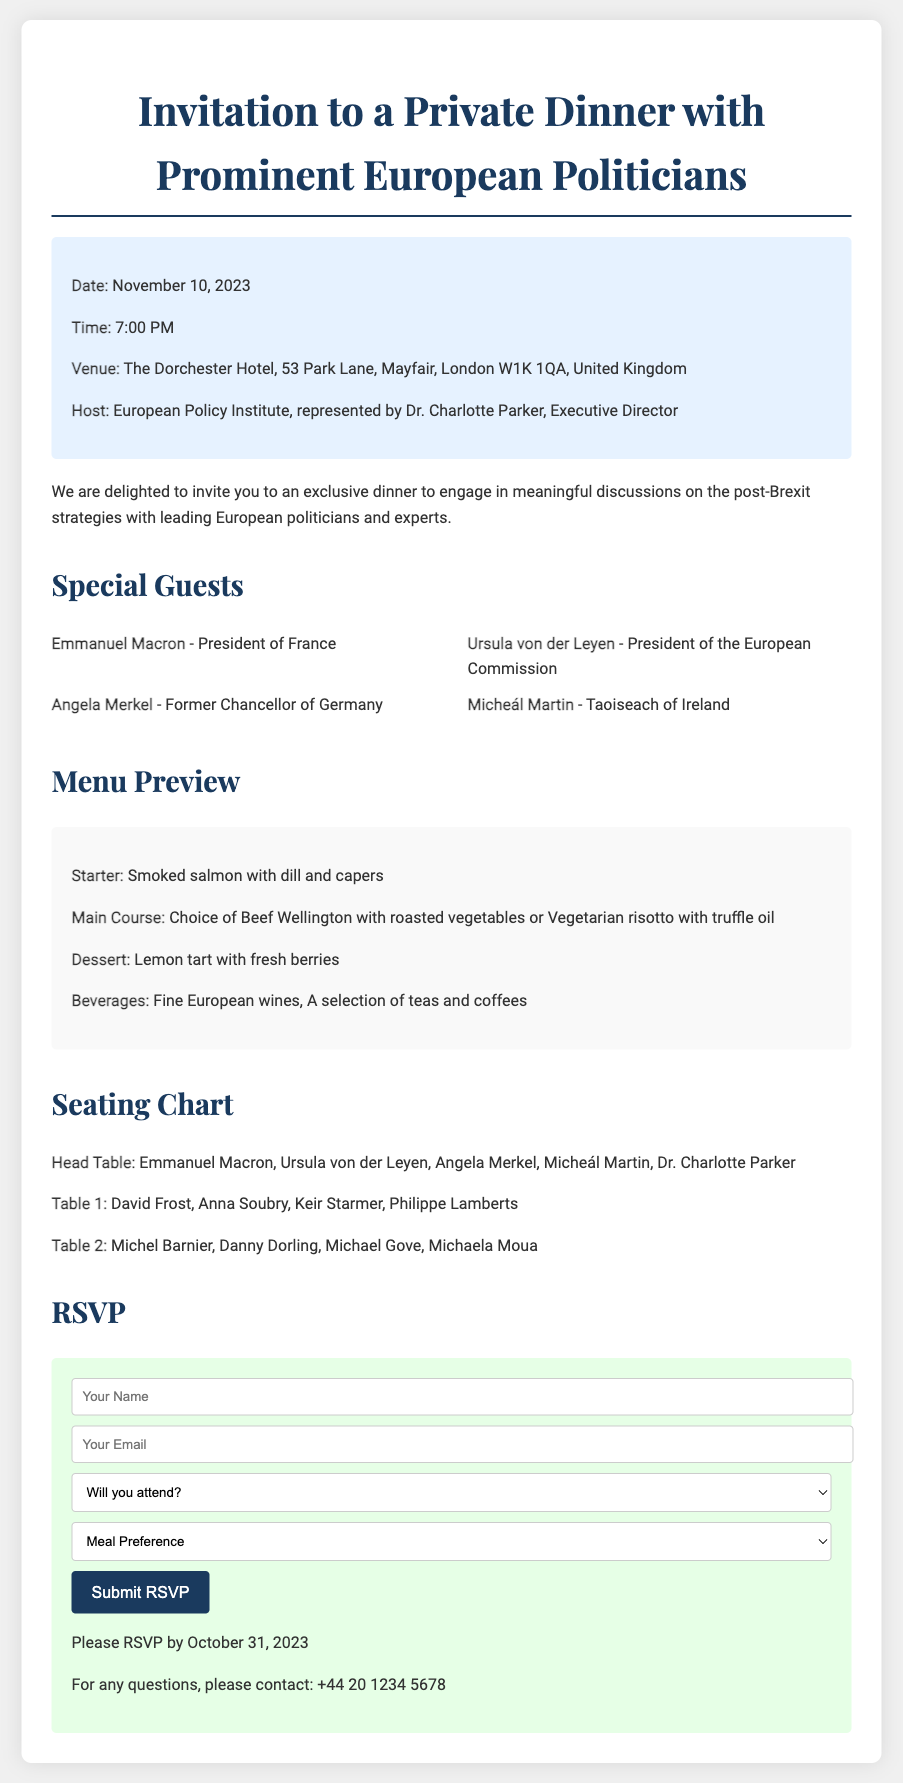What is the date of the dinner? The document specifies that the dinner is scheduled for November 10, 2023.
Answer: November 10, 2023 Who is the host of the dinner? The host of the dinner is the European Policy Institute, represented by Dr. Charlotte Parker.
Answer: European Policy Institute, Dr. Charlotte Parker What is one of the starter options on the menu? The menu preview includes smoked salmon with dill and capers as a starter option.
Answer: Smoked salmon with dill and capers What is the location of the event? The venue for the dinner is The Dorchester Hotel, located at 53 Park Lane, Mayfair, London W1K 1QA, United Kingdom.
Answer: The Dorchester Hotel, 53 Park Lane, Mayfair, London W1K 1QA, United Kingdom How many special guests are listed? The document lists four special guests attending the dinner.
Answer: Four Which dish is offered as a dessert? According to the menu preview, the dessert option is a lemon tart with fresh berries.
Answer: Lemon tart with fresh berries What is the deadline for RSVP? The RSVP deadline mentioned in the document is October 31, 2023.
Answer: October 31, 2023 Who will be seated at the head table? The head table includes Emmanuel Macron, Ursula von der Leyen, Angela Merkel, Micheál Martin, and Dr. Charlotte Parker.
Answer: Emmanuel Macron, Ursula von der Leyen, Angela Merkel, Micheál Martin, Dr. Charlotte Parker What is the action required to submit an RSVP? The document indicates that attendees need to fill out a form and submit it via email.
Answer: Submit it via email 